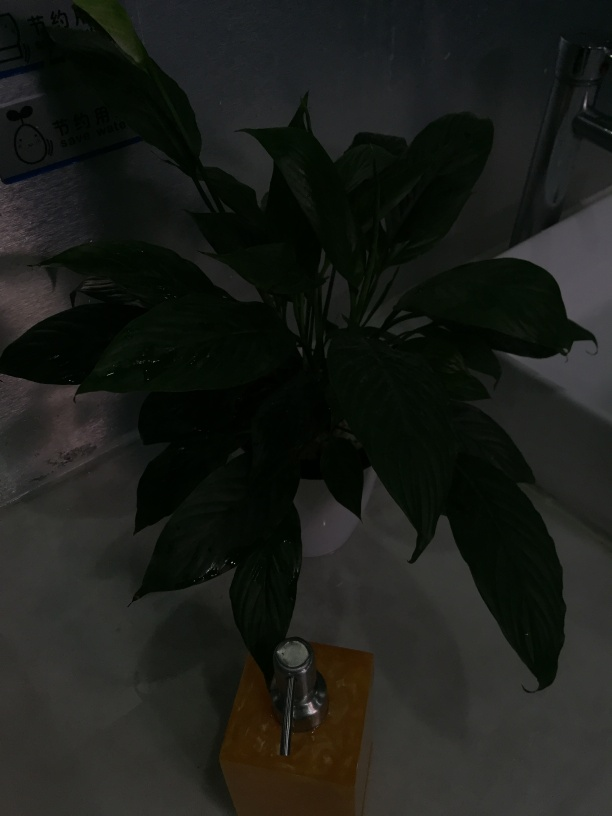Can you explain why the plant might appear so dark in this image? Certainly! The darkness of the plant in the image is likely due to a combination of low ambient lighting and a camera setting that does not compensate for it. As a result, the camera sensor has not captured enough light, leading to an underexposed photo where details are difficult to discern. How might one improve the quality of this photo? Improving the photo's quality could involve adjusting the camera's exposure settings, like increasing the ISO or slowing down the shutter speed to allow more light in. Alternatively, one could add more artificial light to the scene or use photo editing software to brighten the image post-capture. 